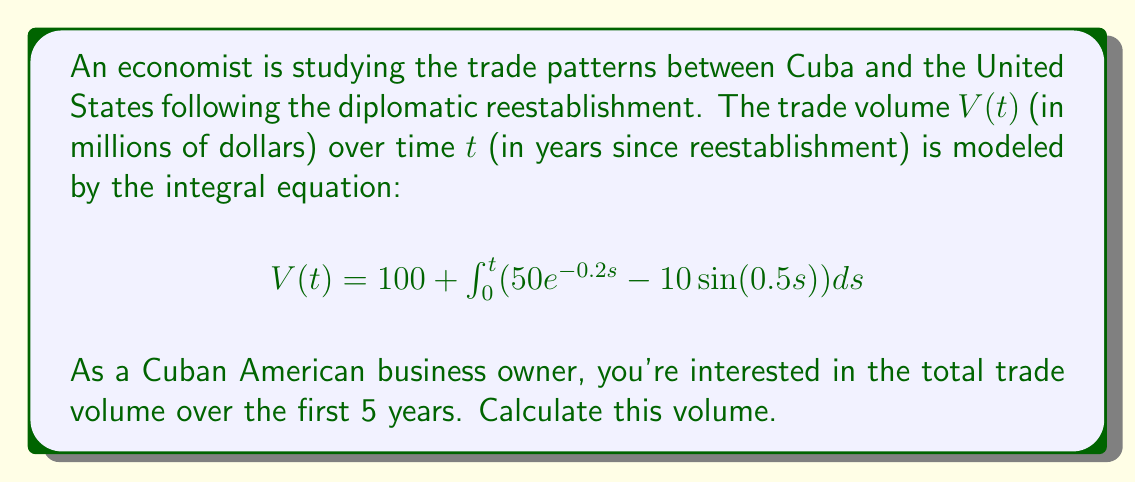Give your solution to this math problem. To solve this problem, we need to evaluate the definite integral from 0 to 5:

1) First, let's solve the indefinite integral:

   $$\int (50e^{-0.2s} - 10\sin(0.5s)) ds$$

2) For $50e^{-0.2s}$:
   $$\int 50e^{-0.2s} ds = -250e^{-0.2s} + C$$

3) For $-10\sin(0.5s)$:
   $$\int -10\sin(0.5s) ds = 20\cos(0.5s) + C$$

4) Combining these results:
   $$\int (50e^{-0.2s} - 10\sin(0.5s)) ds = -250e^{-0.2s} + 20\cos(0.5s) + C$$

5) Now, we can apply the fundamental theorem of calculus:

   $$V(t) = 100 + [-250e^{-0.2s} + 20\cos(0.5s)]_0^t$$

6) Evaluating at the limits:
   $$V(t) = 100 + [-250e^{-0.2t} + 20\cos(0.5t)] - [-250 + 20]$$

7) Simplifying:
   $$V(t) = 100 + 250 - 20 - 250e^{-0.2t} + 20\cos(0.5t)$$
   $$V(t) = 330 - 250e^{-0.2t} + 20\cos(0.5t)$$

8) To find the total volume over 5 years, we evaluate $V(5)$:
   $$V(5) = 330 - 250e^{-1} + 20\cos(2.5)$$

9) Calculate the numerical value:
   $$V(5) \approx 330 - 91.97 - 10.32 = 227.71$$

Therefore, the total trade volume over the first 5 years is approximately 227.71 million dollars.
Answer: $227.71$ million dollars 